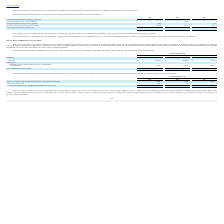From Ringcentral's financial document, What are the respective weighted-average common shares for basic and diluted net loss per share in 2017 and 2018? The document shows two values: 76,281 and 79,500 (in thousands). From the document: "loss per share 83,130 79,500 76,281 loss per share 83,130 79,500 76,281..." Also, What are the respective eighted-average common shares for basic and diluted net loss per share in 2018 and 2019? The document shows two values: 79,500 and 83,130 (in thousands). From the document: "loss per share 83,130 79,500 76,281 loss per share 83,130 79,500 76,281..." Also, What are the respective basic and diluted net loss per share in 2017 and 2018? The document shows two values: (0.06) and (0.33). From the document: "and diluted net loss per share $ (0.64) $ (0.33) $ (0.06) Basic and diluted net loss per share $ (0.64) $ (0.33) $ (0.06)..." Also, can you calculate: What is the change in the weighted-average common shares for basic and diluted net loss per share between 2017 and 2018? Based on the calculation: 79,500 - 76,281 , the result is 3219 (in thousands). This is based on the information: "loss per share 83,130 79,500 76,281 loss per share 83,130 79,500 76,281..." The key data points involved are: 76,281, 79,500. Also, can you calculate: What is the percentage change in the weighted-average common shares for basic and diluted net loss per share between 2017 and 2018? To answer this question, I need to perform calculations using the financial data. The calculation is: (79,500 - 76,281)/76,281 , which equals 4.22 (percentage). This is based on the information: "loss per share 83,130 79,500 76,281 loss per share 83,130 79,500 76,281..." The key data points involved are: 76,281, 79,500. Also, can you calculate: What is the percentage change in the weighted-average common shares for basic and diluted net loss per share between 2018 and 2019? To answer this question, I need to perform calculations using the financial data. The calculation is: (83,130 - 79,500)/79,500 , which equals 4.57 (percentage). This is based on the information: "loss per share 83,130 79,500 76,281 loss per share 83,130 79,500 76,281..." The key data points involved are: 79,500, 83,130. 